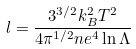Convert formula to latex. <formula><loc_0><loc_0><loc_500><loc_500>l = \frac { 3 ^ { 3 / 2 } k ^ { 2 } _ { B } T ^ { 2 } } { 4 \pi ^ { 1 / 2 } n e ^ { 4 } \ln { \Lambda } }</formula> 